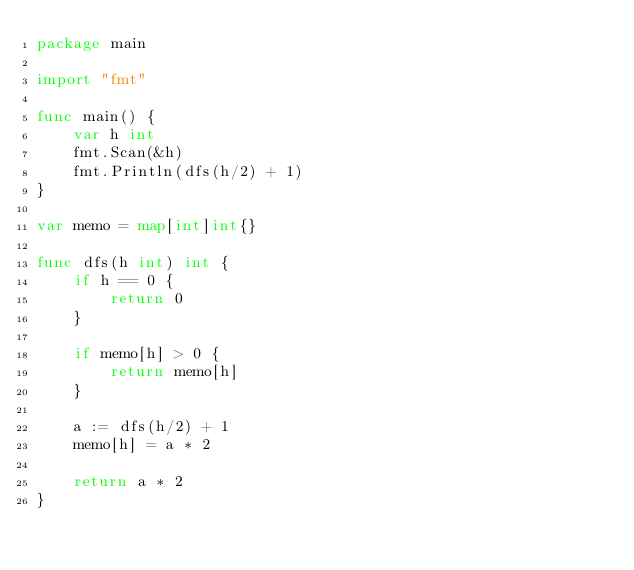<code> <loc_0><loc_0><loc_500><loc_500><_Go_>package main

import "fmt"

func main() {
	var h int
	fmt.Scan(&h)
	fmt.Println(dfs(h/2) + 1)
}

var memo = map[int]int{}

func dfs(h int) int {
	if h == 0 {
		return 0
	}

	if memo[h] > 0 {
		return memo[h]
	}

	a := dfs(h/2) + 1
	memo[h] = a * 2

	return a * 2
}
</code> 